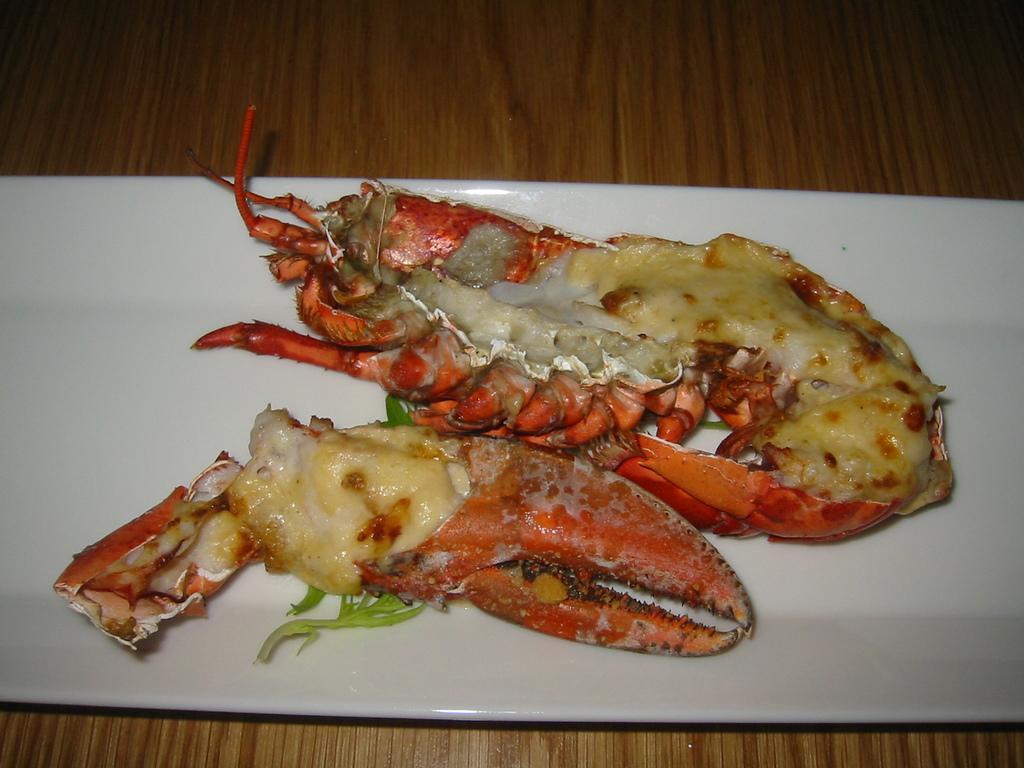How would you summarize this image in a sentence or two? In this image there is a food item served in a plate and the plate is on the table. 